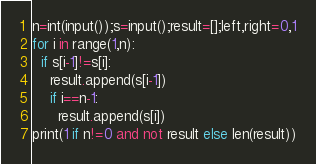<code> <loc_0><loc_0><loc_500><loc_500><_Python_>n=int(input());s=input();result=[];left,right=0,1
for i in range(1,n):
  if s[i-1]!=s[i]:
    result.append(s[i-1])
    if i==n-1:
      result.append(s[i])
print(1 if n!=0 and not result else len(result))</code> 